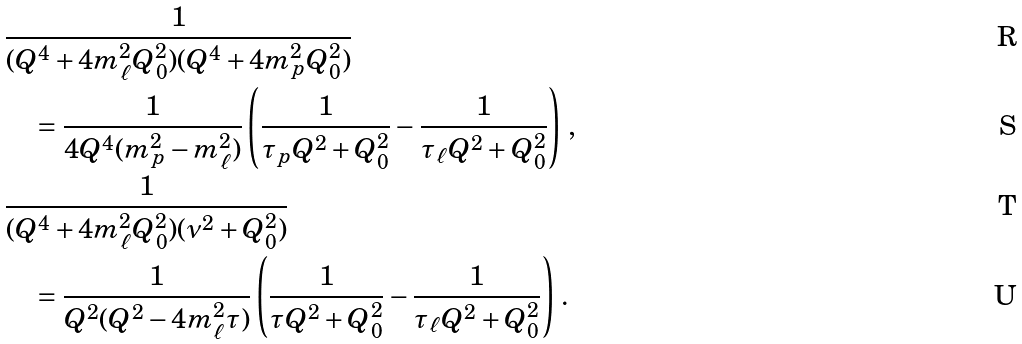<formula> <loc_0><loc_0><loc_500><loc_500>& \frac { 1 } { ( Q ^ { 4 } + 4 m _ { \ell } ^ { 2 } Q _ { 0 } ^ { 2 } ) ( Q ^ { 4 } + 4 m _ { p } ^ { 2 } Q _ { 0 } ^ { 2 } ) } \\ & \quad = \frac { 1 } { 4 Q ^ { 4 } ( m _ { p } ^ { 2 } - m _ { \ell } ^ { 2 } ) } \left ( \frac { 1 } { \tau _ { p } Q ^ { 2 } + Q _ { 0 } ^ { 2 } } - \frac { 1 } { \tau _ { \ell } Q ^ { 2 } + Q _ { 0 } ^ { 2 } } \right ) \, , \\ & \frac { 1 } { ( Q ^ { 4 } + 4 m _ { \ell } ^ { 2 } Q _ { 0 } ^ { 2 } ) ( { \nu } ^ { 2 } + Q _ { 0 } ^ { 2 } ) } \\ & \quad = \frac { 1 } { Q ^ { 2 } ( Q ^ { 2 } - 4 m _ { \ell } ^ { 2 } \tau ) } \left ( \frac { 1 } { \tau Q ^ { 2 } + Q _ { 0 } ^ { 2 } } - \frac { 1 } { \tau _ { \ell } Q ^ { 2 } + Q _ { 0 } ^ { 2 } } \right ) \, .</formula> 